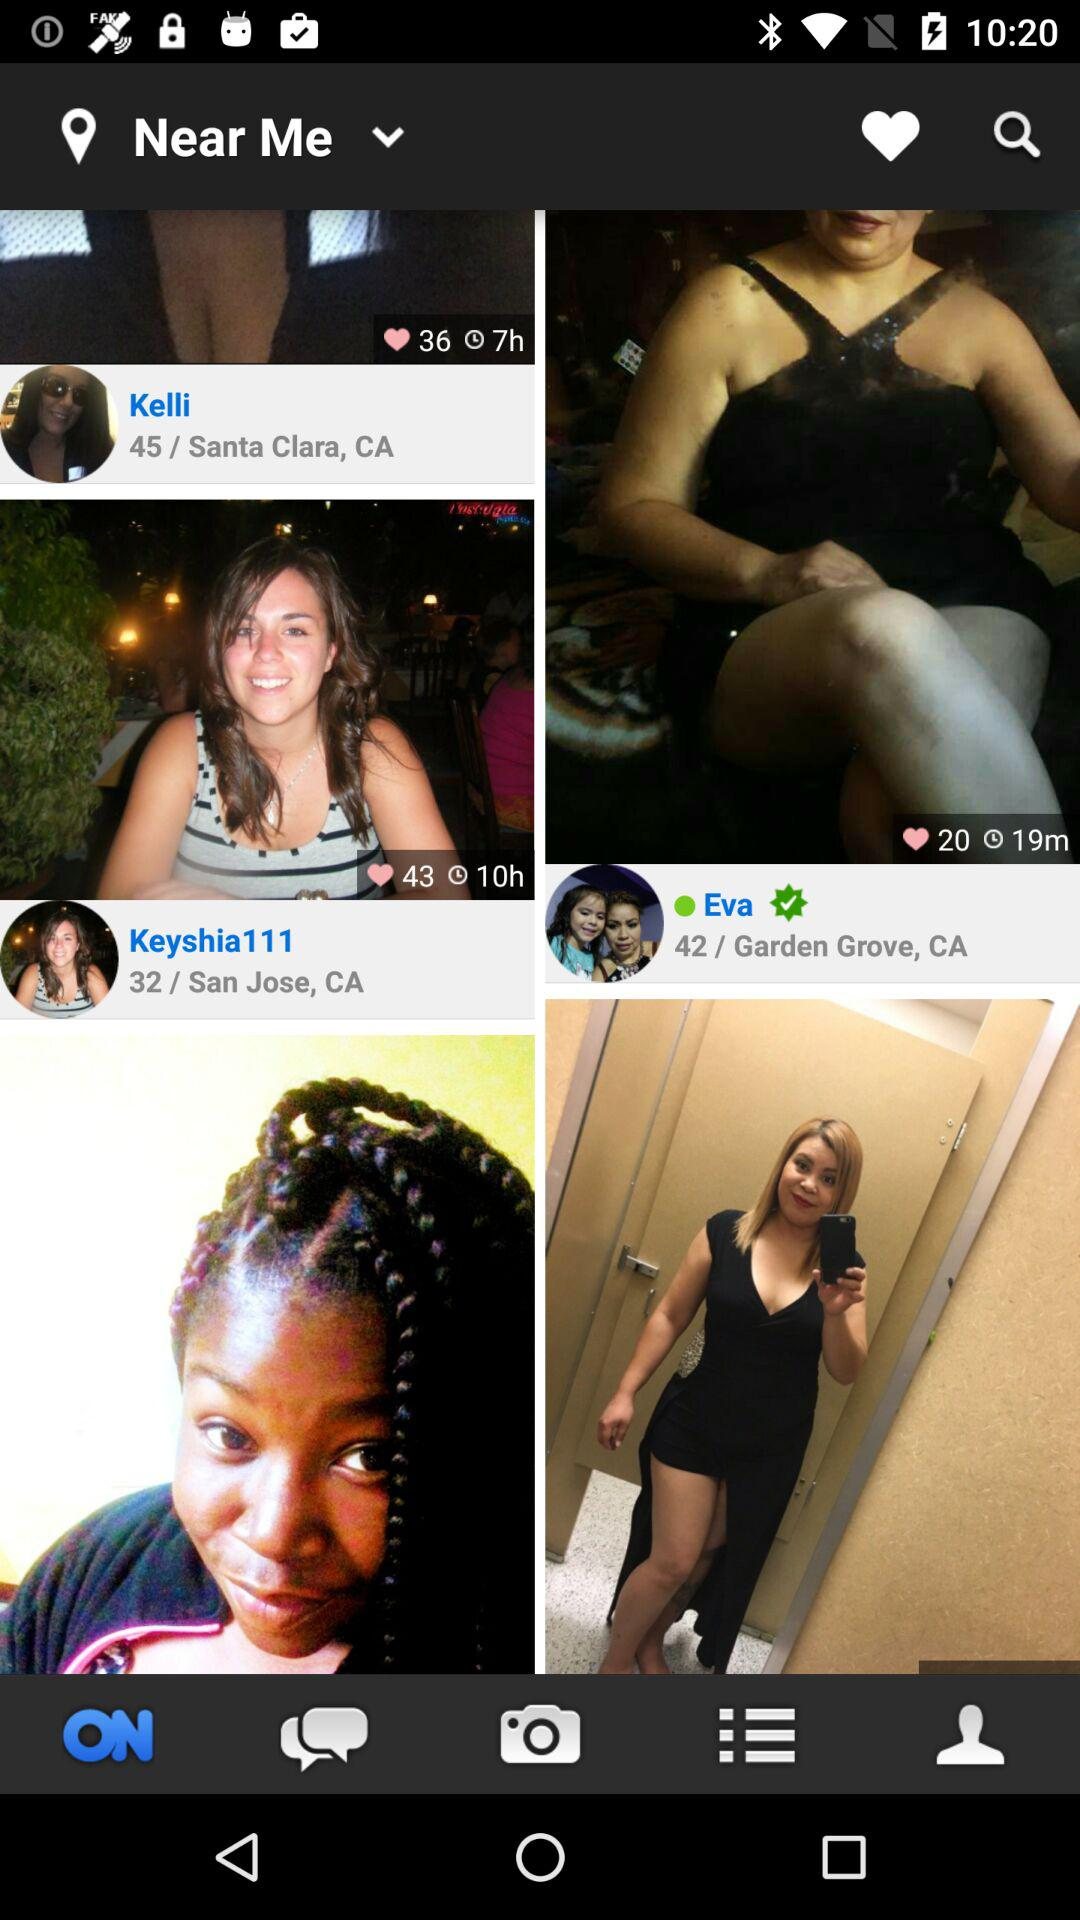What is the location of Eva? Eva's location is Garden Grove, CA. 